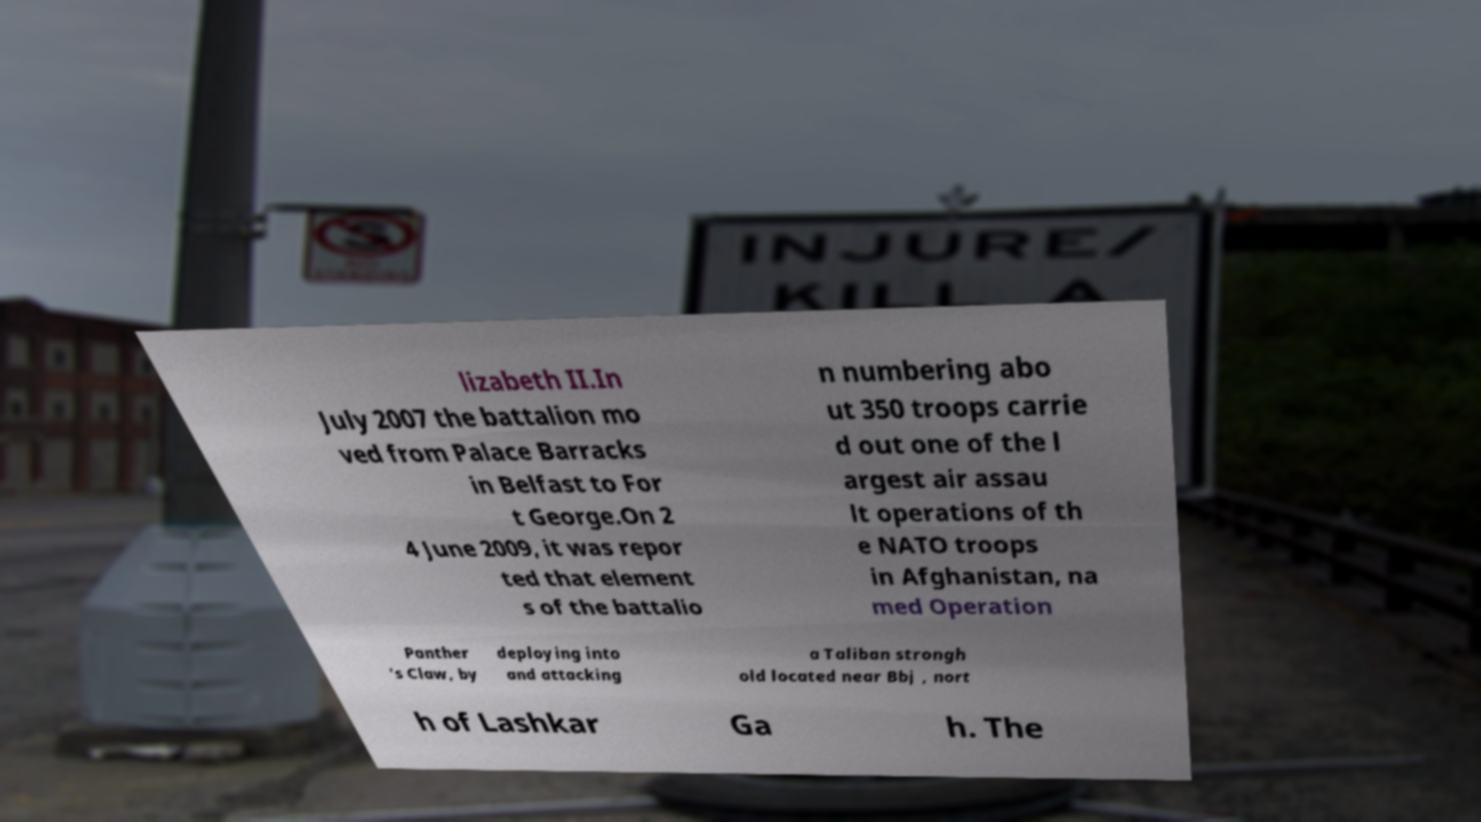Please identify and transcribe the text found in this image. lizabeth II.In July 2007 the battalion mo ved from Palace Barracks in Belfast to For t George.On 2 4 June 2009, it was repor ted that element s of the battalio n numbering abo ut 350 troops carrie d out one of the l argest air assau lt operations of th e NATO troops in Afghanistan, na med Operation Panther 's Claw, by deploying into and attacking a Taliban strongh old located near Bbj , nort h of Lashkar Ga h. The 